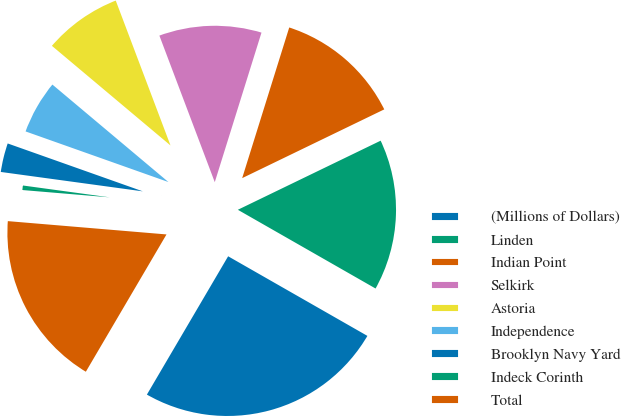Convert chart. <chart><loc_0><loc_0><loc_500><loc_500><pie_chart><fcel>(Millions of Dollars)<fcel>Linden<fcel>Indian Point<fcel>Selkirk<fcel>Astoria<fcel>Independence<fcel>Brooklyn Navy Yard<fcel>Indeck Corinth<fcel>Total<nl><fcel>25.19%<fcel>15.44%<fcel>13.01%<fcel>10.57%<fcel>8.13%<fcel>5.7%<fcel>3.26%<fcel>0.83%<fcel>17.88%<nl></chart> 